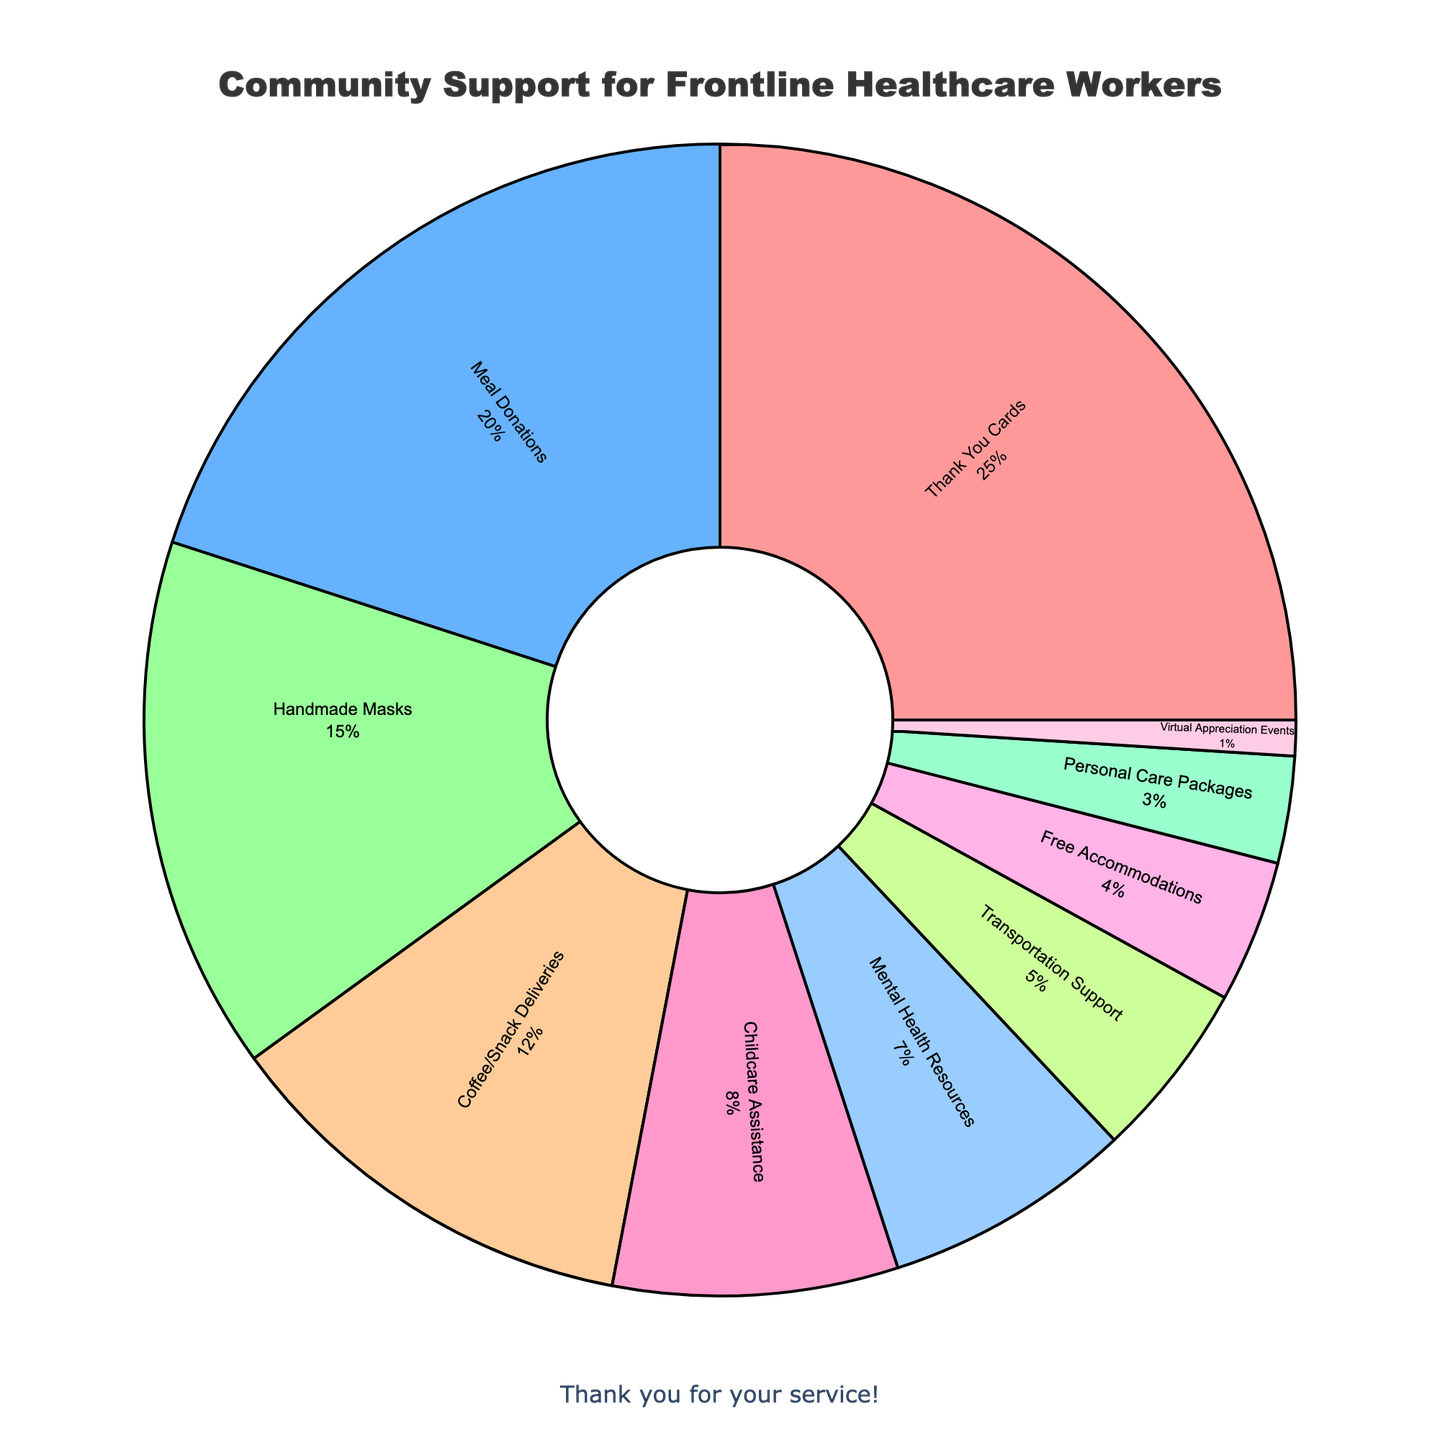Which type of support received the highest percentage? The chart shows that "Thank You Cards" has the largest segment in the pie chart.
Answer: Thank You Cards Which type of support is more common: Meal Donations or Handmade Masks? By comparing the sizes of the segments, Meal Donations (20%) is larger than Handmade Masks (15%).
Answer: Meal Donations What is the combined percentage of support types that fall below 10%? Add the percentages of Childcare Assistance (8%), Mental Health Resources (7%), Transportation Support (5%), Free Accommodations (4%), Personal Care Packages (3%), and Virtual Appreciation Events (1%). The total is 8 + 7 + 5 + 4 + 3 + 1 = 28%.
Answer: 28% How do the percentages for Childcare Assistance and Mental Health Resources compare? The chart shows Childcare Assistance is 8% and Mental Health Resources is 7%. Since 8% > 7%, Childcare Assistance is greater.
Answer: Childcare Assistance Which two types of support combined make up half of the total support? Add up the largest segments until reaching or exceeding 50%: Thank You Cards (25%) and Meal Donations (20%) together make 25 + 20 = 45%. However, adding Handmade Masks (15%) would exceed 50%, so Thank You Cards and Meal Donations combined do not make half the total. Instead, add Thank You Cards (25%) and Handmade Masks (15%) to get 25 + 15 = 40%, then add Meal Donations (20%) to get 40 + 20 = 60%. Instead, consider largest two that make around half: Thank You Cards (25%) and Meal Donations (20%) which alone make 45%. Therefore exact 50% is not precisely possible. Two of top three can approximate near.
Answer: Combined of top 2 or 3 Which supports have less than half the percentage of Coffee/Snack Deliveries? Coffee/Snack Deliveries is 12%, so half of it is 6%. Mental Health Resources (7%), Transportation Support (5%), Free Accommodations (4%), Personal Care Packages (3%), and Virtual Appreciation Events (1%) are all below 6%.
Answer: Mental Health Resources, Transportation Support, Free Accommodations, Personal Care Packages, Virtual Appreciation Events Is there any type of support that makes up exactly 15% of the total? Inspect the chart for a segment labeled "15%". The segment for Handmade Masks is exactly 15%.
Answer: Handmade Masks What is the smallest type of support shown in the pie chart? The segment labeled with the smallest percentage is "Virtual Appreciation Events" with 1%.
Answer: Virtual Appreciation Events 